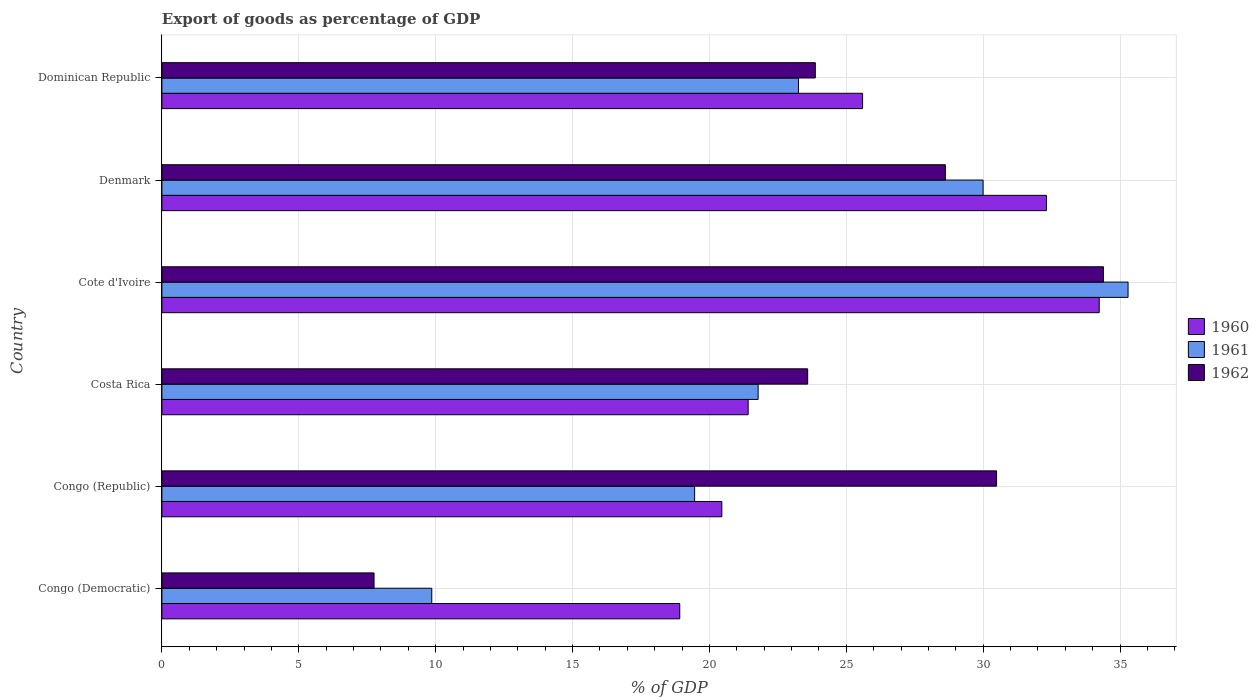How many bars are there on the 2nd tick from the top?
Your answer should be very brief. 3. How many bars are there on the 6th tick from the bottom?
Provide a succinct answer. 3. What is the label of the 5th group of bars from the top?
Offer a very short reply. Congo (Republic). In how many cases, is the number of bars for a given country not equal to the number of legend labels?
Provide a short and direct response. 0. What is the export of goods as percentage of GDP in 1962 in Cote d'Ivoire?
Your response must be concise. 34.39. Across all countries, what is the maximum export of goods as percentage of GDP in 1960?
Provide a short and direct response. 34.24. Across all countries, what is the minimum export of goods as percentage of GDP in 1960?
Ensure brevity in your answer.  18.92. In which country was the export of goods as percentage of GDP in 1962 maximum?
Your answer should be very brief. Cote d'Ivoire. In which country was the export of goods as percentage of GDP in 1962 minimum?
Your answer should be very brief. Congo (Democratic). What is the total export of goods as percentage of GDP in 1960 in the graph?
Your response must be concise. 152.93. What is the difference between the export of goods as percentage of GDP in 1960 in Congo (Republic) and that in Denmark?
Provide a succinct answer. -11.86. What is the difference between the export of goods as percentage of GDP in 1962 in Congo (Republic) and the export of goods as percentage of GDP in 1960 in Dominican Republic?
Make the answer very short. 4.89. What is the average export of goods as percentage of GDP in 1962 per country?
Your response must be concise. 24.78. What is the difference between the export of goods as percentage of GDP in 1960 and export of goods as percentage of GDP in 1961 in Congo (Republic)?
Provide a succinct answer. 0.99. What is the ratio of the export of goods as percentage of GDP in 1961 in Costa Rica to that in Dominican Republic?
Make the answer very short. 0.94. Is the export of goods as percentage of GDP in 1960 in Congo (Democratic) less than that in Dominican Republic?
Your answer should be very brief. Yes. What is the difference between the highest and the second highest export of goods as percentage of GDP in 1961?
Keep it short and to the point. 5.3. What is the difference between the highest and the lowest export of goods as percentage of GDP in 1962?
Give a very brief answer. 26.64. Is the sum of the export of goods as percentage of GDP in 1961 in Congo (Democratic) and Cote d'Ivoire greater than the maximum export of goods as percentage of GDP in 1960 across all countries?
Make the answer very short. Yes. Does the graph contain grids?
Your answer should be compact. Yes. How are the legend labels stacked?
Offer a very short reply. Vertical. What is the title of the graph?
Offer a very short reply. Export of goods as percentage of GDP. What is the label or title of the X-axis?
Your answer should be very brief. % of GDP. What is the label or title of the Y-axis?
Make the answer very short. Country. What is the % of GDP of 1960 in Congo (Democratic)?
Give a very brief answer. 18.92. What is the % of GDP of 1961 in Congo (Democratic)?
Ensure brevity in your answer.  9.86. What is the % of GDP in 1962 in Congo (Democratic)?
Make the answer very short. 7.75. What is the % of GDP in 1960 in Congo (Republic)?
Offer a terse response. 20.45. What is the % of GDP of 1961 in Congo (Republic)?
Offer a terse response. 19.46. What is the % of GDP of 1962 in Congo (Republic)?
Provide a succinct answer. 30.49. What is the % of GDP in 1960 in Costa Rica?
Your answer should be compact. 21.42. What is the % of GDP of 1961 in Costa Rica?
Give a very brief answer. 21.78. What is the % of GDP of 1962 in Costa Rica?
Provide a succinct answer. 23.59. What is the % of GDP in 1960 in Cote d'Ivoire?
Keep it short and to the point. 34.24. What is the % of GDP of 1961 in Cote d'Ivoire?
Provide a succinct answer. 35.29. What is the % of GDP of 1962 in Cote d'Ivoire?
Your answer should be compact. 34.39. What is the % of GDP of 1960 in Denmark?
Make the answer very short. 32.31. What is the % of GDP of 1961 in Denmark?
Your answer should be compact. 30. What is the % of GDP of 1962 in Denmark?
Ensure brevity in your answer.  28.62. What is the % of GDP in 1960 in Dominican Republic?
Keep it short and to the point. 25.59. What is the % of GDP in 1961 in Dominican Republic?
Your response must be concise. 23.25. What is the % of GDP in 1962 in Dominican Republic?
Your answer should be compact. 23.87. Across all countries, what is the maximum % of GDP of 1960?
Ensure brevity in your answer.  34.24. Across all countries, what is the maximum % of GDP of 1961?
Keep it short and to the point. 35.29. Across all countries, what is the maximum % of GDP in 1962?
Ensure brevity in your answer.  34.39. Across all countries, what is the minimum % of GDP of 1960?
Make the answer very short. 18.92. Across all countries, what is the minimum % of GDP of 1961?
Give a very brief answer. 9.86. Across all countries, what is the minimum % of GDP in 1962?
Ensure brevity in your answer.  7.75. What is the total % of GDP of 1960 in the graph?
Offer a terse response. 152.93. What is the total % of GDP in 1961 in the graph?
Your answer should be very brief. 139.64. What is the total % of GDP of 1962 in the graph?
Your response must be concise. 148.71. What is the difference between the % of GDP of 1960 in Congo (Democratic) and that in Congo (Republic)?
Offer a very short reply. -1.54. What is the difference between the % of GDP in 1961 in Congo (Democratic) and that in Congo (Republic)?
Your answer should be very brief. -9.6. What is the difference between the % of GDP of 1962 in Congo (Democratic) and that in Congo (Republic)?
Provide a succinct answer. -22.74. What is the difference between the % of GDP in 1960 in Congo (Democratic) and that in Costa Rica?
Make the answer very short. -2.5. What is the difference between the % of GDP in 1961 in Congo (Democratic) and that in Costa Rica?
Ensure brevity in your answer.  -11.92. What is the difference between the % of GDP of 1962 in Congo (Democratic) and that in Costa Rica?
Your answer should be compact. -15.84. What is the difference between the % of GDP in 1960 in Congo (Democratic) and that in Cote d'Ivoire?
Offer a terse response. -15.32. What is the difference between the % of GDP of 1961 in Congo (Democratic) and that in Cote d'Ivoire?
Ensure brevity in your answer.  -25.43. What is the difference between the % of GDP of 1962 in Congo (Democratic) and that in Cote d'Ivoire?
Provide a short and direct response. -26.64. What is the difference between the % of GDP in 1960 in Congo (Democratic) and that in Denmark?
Your answer should be compact. -13.39. What is the difference between the % of GDP in 1961 in Congo (Democratic) and that in Denmark?
Offer a terse response. -20.14. What is the difference between the % of GDP of 1962 in Congo (Democratic) and that in Denmark?
Offer a terse response. -20.87. What is the difference between the % of GDP in 1960 in Congo (Democratic) and that in Dominican Republic?
Your answer should be compact. -6.68. What is the difference between the % of GDP of 1961 in Congo (Democratic) and that in Dominican Republic?
Offer a very short reply. -13.4. What is the difference between the % of GDP in 1962 in Congo (Democratic) and that in Dominican Republic?
Provide a short and direct response. -16.12. What is the difference between the % of GDP of 1960 in Congo (Republic) and that in Costa Rica?
Offer a terse response. -0.96. What is the difference between the % of GDP in 1961 in Congo (Republic) and that in Costa Rica?
Provide a succinct answer. -2.32. What is the difference between the % of GDP in 1962 in Congo (Republic) and that in Costa Rica?
Your answer should be very brief. 6.9. What is the difference between the % of GDP in 1960 in Congo (Republic) and that in Cote d'Ivoire?
Make the answer very short. -13.79. What is the difference between the % of GDP of 1961 in Congo (Republic) and that in Cote d'Ivoire?
Provide a short and direct response. -15.83. What is the difference between the % of GDP in 1962 in Congo (Republic) and that in Cote d'Ivoire?
Your answer should be very brief. -3.9. What is the difference between the % of GDP in 1960 in Congo (Republic) and that in Denmark?
Offer a very short reply. -11.86. What is the difference between the % of GDP of 1961 in Congo (Republic) and that in Denmark?
Provide a succinct answer. -10.54. What is the difference between the % of GDP of 1962 in Congo (Republic) and that in Denmark?
Ensure brevity in your answer.  1.87. What is the difference between the % of GDP of 1960 in Congo (Republic) and that in Dominican Republic?
Provide a short and direct response. -5.14. What is the difference between the % of GDP of 1961 in Congo (Republic) and that in Dominican Republic?
Your answer should be very brief. -3.79. What is the difference between the % of GDP of 1962 in Congo (Republic) and that in Dominican Republic?
Provide a succinct answer. 6.62. What is the difference between the % of GDP in 1960 in Costa Rica and that in Cote d'Ivoire?
Provide a short and direct response. -12.82. What is the difference between the % of GDP of 1961 in Costa Rica and that in Cote d'Ivoire?
Keep it short and to the point. -13.51. What is the difference between the % of GDP of 1962 in Costa Rica and that in Cote d'Ivoire?
Make the answer very short. -10.8. What is the difference between the % of GDP of 1960 in Costa Rica and that in Denmark?
Keep it short and to the point. -10.89. What is the difference between the % of GDP of 1961 in Costa Rica and that in Denmark?
Offer a terse response. -8.22. What is the difference between the % of GDP in 1962 in Costa Rica and that in Denmark?
Provide a succinct answer. -5.03. What is the difference between the % of GDP in 1960 in Costa Rica and that in Dominican Republic?
Provide a short and direct response. -4.18. What is the difference between the % of GDP of 1961 in Costa Rica and that in Dominican Republic?
Give a very brief answer. -1.47. What is the difference between the % of GDP in 1962 in Costa Rica and that in Dominican Republic?
Ensure brevity in your answer.  -0.28. What is the difference between the % of GDP of 1960 in Cote d'Ivoire and that in Denmark?
Give a very brief answer. 1.93. What is the difference between the % of GDP of 1961 in Cote d'Ivoire and that in Denmark?
Offer a very short reply. 5.3. What is the difference between the % of GDP in 1962 in Cote d'Ivoire and that in Denmark?
Your response must be concise. 5.77. What is the difference between the % of GDP of 1960 in Cote d'Ivoire and that in Dominican Republic?
Provide a short and direct response. 8.64. What is the difference between the % of GDP of 1961 in Cote d'Ivoire and that in Dominican Republic?
Give a very brief answer. 12.04. What is the difference between the % of GDP in 1962 in Cote d'Ivoire and that in Dominican Republic?
Keep it short and to the point. 10.52. What is the difference between the % of GDP in 1960 in Denmark and that in Dominican Republic?
Offer a very short reply. 6.72. What is the difference between the % of GDP in 1961 in Denmark and that in Dominican Republic?
Your response must be concise. 6.74. What is the difference between the % of GDP of 1962 in Denmark and that in Dominican Republic?
Ensure brevity in your answer.  4.75. What is the difference between the % of GDP in 1960 in Congo (Democratic) and the % of GDP in 1961 in Congo (Republic)?
Your answer should be compact. -0.54. What is the difference between the % of GDP in 1960 in Congo (Democratic) and the % of GDP in 1962 in Congo (Republic)?
Your answer should be very brief. -11.57. What is the difference between the % of GDP in 1961 in Congo (Democratic) and the % of GDP in 1962 in Congo (Republic)?
Provide a short and direct response. -20.63. What is the difference between the % of GDP in 1960 in Congo (Democratic) and the % of GDP in 1961 in Costa Rica?
Ensure brevity in your answer.  -2.86. What is the difference between the % of GDP of 1960 in Congo (Democratic) and the % of GDP of 1962 in Costa Rica?
Keep it short and to the point. -4.67. What is the difference between the % of GDP of 1961 in Congo (Democratic) and the % of GDP of 1962 in Costa Rica?
Give a very brief answer. -13.73. What is the difference between the % of GDP in 1960 in Congo (Democratic) and the % of GDP in 1961 in Cote d'Ivoire?
Keep it short and to the point. -16.38. What is the difference between the % of GDP of 1960 in Congo (Democratic) and the % of GDP of 1962 in Cote d'Ivoire?
Give a very brief answer. -15.48. What is the difference between the % of GDP of 1961 in Congo (Democratic) and the % of GDP of 1962 in Cote d'Ivoire?
Offer a terse response. -24.53. What is the difference between the % of GDP in 1960 in Congo (Democratic) and the % of GDP in 1961 in Denmark?
Provide a short and direct response. -11.08. What is the difference between the % of GDP of 1960 in Congo (Democratic) and the % of GDP of 1962 in Denmark?
Ensure brevity in your answer.  -9.7. What is the difference between the % of GDP in 1961 in Congo (Democratic) and the % of GDP in 1962 in Denmark?
Your response must be concise. -18.76. What is the difference between the % of GDP in 1960 in Congo (Democratic) and the % of GDP in 1961 in Dominican Republic?
Give a very brief answer. -4.34. What is the difference between the % of GDP of 1960 in Congo (Democratic) and the % of GDP of 1962 in Dominican Republic?
Ensure brevity in your answer.  -4.95. What is the difference between the % of GDP of 1961 in Congo (Democratic) and the % of GDP of 1962 in Dominican Republic?
Your response must be concise. -14.01. What is the difference between the % of GDP in 1960 in Congo (Republic) and the % of GDP in 1961 in Costa Rica?
Provide a succinct answer. -1.33. What is the difference between the % of GDP of 1960 in Congo (Republic) and the % of GDP of 1962 in Costa Rica?
Make the answer very short. -3.14. What is the difference between the % of GDP of 1961 in Congo (Republic) and the % of GDP of 1962 in Costa Rica?
Keep it short and to the point. -4.13. What is the difference between the % of GDP of 1960 in Congo (Republic) and the % of GDP of 1961 in Cote d'Ivoire?
Provide a succinct answer. -14.84. What is the difference between the % of GDP in 1960 in Congo (Republic) and the % of GDP in 1962 in Cote d'Ivoire?
Give a very brief answer. -13.94. What is the difference between the % of GDP of 1961 in Congo (Republic) and the % of GDP of 1962 in Cote d'Ivoire?
Your answer should be very brief. -14.93. What is the difference between the % of GDP of 1960 in Congo (Republic) and the % of GDP of 1961 in Denmark?
Offer a very short reply. -9.54. What is the difference between the % of GDP of 1960 in Congo (Republic) and the % of GDP of 1962 in Denmark?
Provide a short and direct response. -8.17. What is the difference between the % of GDP in 1961 in Congo (Republic) and the % of GDP in 1962 in Denmark?
Give a very brief answer. -9.16. What is the difference between the % of GDP of 1960 in Congo (Republic) and the % of GDP of 1961 in Dominican Republic?
Ensure brevity in your answer.  -2.8. What is the difference between the % of GDP of 1960 in Congo (Republic) and the % of GDP of 1962 in Dominican Republic?
Ensure brevity in your answer.  -3.42. What is the difference between the % of GDP in 1961 in Congo (Republic) and the % of GDP in 1962 in Dominican Republic?
Keep it short and to the point. -4.41. What is the difference between the % of GDP in 1960 in Costa Rica and the % of GDP in 1961 in Cote d'Ivoire?
Offer a very short reply. -13.88. What is the difference between the % of GDP in 1960 in Costa Rica and the % of GDP in 1962 in Cote d'Ivoire?
Ensure brevity in your answer.  -12.98. What is the difference between the % of GDP in 1961 in Costa Rica and the % of GDP in 1962 in Cote d'Ivoire?
Provide a succinct answer. -12.61. What is the difference between the % of GDP in 1960 in Costa Rica and the % of GDP in 1961 in Denmark?
Offer a very short reply. -8.58. What is the difference between the % of GDP in 1960 in Costa Rica and the % of GDP in 1962 in Denmark?
Give a very brief answer. -7.2. What is the difference between the % of GDP in 1961 in Costa Rica and the % of GDP in 1962 in Denmark?
Keep it short and to the point. -6.84. What is the difference between the % of GDP in 1960 in Costa Rica and the % of GDP in 1961 in Dominican Republic?
Your answer should be compact. -1.84. What is the difference between the % of GDP in 1960 in Costa Rica and the % of GDP in 1962 in Dominican Republic?
Provide a short and direct response. -2.45. What is the difference between the % of GDP in 1961 in Costa Rica and the % of GDP in 1962 in Dominican Republic?
Your response must be concise. -2.09. What is the difference between the % of GDP in 1960 in Cote d'Ivoire and the % of GDP in 1961 in Denmark?
Keep it short and to the point. 4.24. What is the difference between the % of GDP in 1960 in Cote d'Ivoire and the % of GDP in 1962 in Denmark?
Offer a very short reply. 5.62. What is the difference between the % of GDP in 1961 in Cote d'Ivoire and the % of GDP in 1962 in Denmark?
Your response must be concise. 6.67. What is the difference between the % of GDP of 1960 in Cote d'Ivoire and the % of GDP of 1961 in Dominican Republic?
Offer a terse response. 10.99. What is the difference between the % of GDP in 1960 in Cote d'Ivoire and the % of GDP in 1962 in Dominican Republic?
Keep it short and to the point. 10.37. What is the difference between the % of GDP in 1961 in Cote d'Ivoire and the % of GDP in 1962 in Dominican Republic?
Ensure brevity in your answer.  11.42. What is the difference between the % of GDP in 1960 in Denmark and the % of GDP in 1961 in Dominican Republic?
Give a very brief answer. 9.06. What is the difference between the % of GDP in 1960 in Denmark and the % of GDP in 1962 in Dominican Republic?
Your answer should be very brief. 8.44. What is the difference between the % of GDP in 1961 in Denmark and the % of GDP in 1962 in Dominican Republic?
Your response must be concise. 6.13. What is the average % of GDP of 1960 per country?
Keep it short and to the point. 25.49. What is the average % of GDP of 1961 per country?
Your answer should be very brief. 23.27. What is the average % of GDP of 1962 per country?
Your answer should be compact. 24.78. What is the difference between the % of GDP in 1960 and % of GDP in 1961 in Congo (Democratic)?
Offer a terse response. 9.06. What is the difference between the % of GDP in 1960 and % of GDP in 1962 in Congo (Democratic)?
Your answer should be very brief. 11.17. What is the difference between the % of GDP in 1961 and % of GDP in 1962 in Congo (Democratic)?
Keep it short and to the point. 2.11. What is the difference between the % of GDP of 1960 and % of GDP of 1961 in Congo (Republic)?
Keep it short and to the point. 0.99. What is the difference between the % of GDP in 1960 and % of GDP in 1962 in Congo (Republic)?
Your answer should be very brief. -10.04. What is the difference between the % of GDP in 1961 and % of GDP in 1962 in Congo (Republic)?
Your answer should be very brief. -11.03. What is the difference between the % of GDP of 1960 and % of GDP of 1961 in Costa Rica?
Provide a short and direct response. -0.36. What is the difference between the % of GDP of 1960 and % of GDP of 1962 in Costa Rica?
Make the answer very short. -2.17. What is the difference between the % of GDP of 1961 and % of GDP of 1962 in Costa Rica?
Offer a terse response. -1.81. What is the difference between the % of GDP in 1960 and % of GDP in 1961 in Cote d'Ivoire?
Ensure brevity in your answer.  -1.05. What is the difference between the % of GDP of 1960 and % of GDP of 1962 in Cote d'Ivoire?
Your answer should be very brief. -0.15. What is the difference between the % of GDP of 1961 and % of GDP of 1962 in Cote d'Ivoire?
Offer a terse response. 0.9. What is the difference between the % of GDP in 1960 and % of GDP in 1961 in Denmark?
Provide a succinct answer. 2.31. What is the difference between the % of GDP in 1960 and % of GDP in 1962 in Denmark?
Provide a succinct answer. 3.69. What is the difference between the % of GDP in 1961 and % of GDP in 1962 in Denmark?
Offer a very short reply. 1.38. What is the difference between the % of GDP in 1960 and % of GDP in 1961 in Dominican Republic?
Your answer should be very brief. 2.34. What is the difference between the % of GDP in 1960 and % of GDP in 1962 in Dominican Republic?
Your answer should be compact. 1.73. What is the difference between the % of GDP in 1961 and % of GDP in 1962 in Dominican Republic?
Provide a short and direct response. -0.62. What is the ratio of the % of GDP of 1960 in Congo (Democratic) to that in Congo (Republic)?
Offer a terse response. 0.92. What is the ratio of the % of GDP in 1961 in Congo (Democratic) to that in Congo (Republic)?
Give a very brief answer. 0.51. What is the ratio of the % of GDP in 1962 in Congo (Democratic) to that in Congo (Republic)?
Offer a terse response. 0.25. What is the ratio of the % of GDP of 1960 in Congo (Democratic) to that in Costa Rica?
Make the answer very short. 0.88. What is the ratio of the % of GDP in 1961 in Congo (Democratic) to that in Costa Rica?
Provide a short and direct response. 0.45. What is the ratio of the % of GDP in 1962 in Congo (Democratic) to that in Costa Rica?
Your answer should be compact. 0.33. What is the ratio of the % of GDP of 1960 in Congo (Democratic) to that in Cote d'Ivoire?
Your answer should be compact. 0.55. What is the ratio of the % of GDP in 1961 in Congo (Democratic) to that in Cote d'Ivoire?
Give a very brief answer. 0.28. What is the ratio of the % of GDP of 1962 in Congo (Democratic) to that in Cote d'Ivoire?
Your answer should be compact. 0.23. What is the ratio of the % of GDP in 1960 in Congo (Democratic) to that in Denmark?
Make the answer very short. 0.59. What is the ratio of the % of GDP in 1961 in Congo (Democratic) to that in Denmark?
Your answer should be compact. 0.33. What is the ratio of the % of GDP in 1962 in Congo (Democratic) to that in Denmark?
Your answer should be very brief. 0.27. What is the ratio of the % of GDP in 1960 in Congo (Democratic) to that in Dominican Republic?
Ensure brevity in your answer.  0.74. What is the ratio of the % of GDP of 1961 in Congo (Democratic) to that in Dominican Republic?
Ensure brevity in your answer.  0.42. What is the ratio of the % of GDP of 1962 in Congo (Democratic) to that in Dominican Republic?
Provide a short and direct response. 0.32. What is the ratio of the % of GDP of 1960 in Congo (Republic) to that in Costa Rica?
Offer a very short reply. 0.96. What is the ratio of the % of GDP in 1961 in Congo (Republic) to that in Costa Rica?
Ensure brevity in your answer.  0.89. What is the ratio of the % of GDP in 1962 in Congo (Republic) to that in Costa Rica?
Make the answer very short. 1.29. What is the ratio of the % of GDP in 1960 in Congo (Republic) to that in Cote d'Ivoire?
Your answer should be very brief. 0.6. What is the ratio of the % of GDP in 1961 in Congo (Republic) to that in Cote d'Ivoire?
Provide a short and direct response. 0.55. What is the ratio of the % of GDP of 1962 in Congo (Republic) to that in Cote d'Ivoire?
Your response must be concise. 0.89. What is the ratio of the % of GDP in 1960 in Congo (Republic) to that in Denmark?
Give a very brief answer. 0.63. What is the ratio of the % of GDP of 1961 in Congo (Republic) to that in Denmark?
Provide a succinct answer. 0.65. What is the ratio of the % of GDP of 1962 in Congo (Republic) to that in Denmark?
Ensure brevity in your answer.  1.07. What is the ratio of the % of GDP of 1960 in Congo (Republic) to that in Dominican Republic?
Keep it short and to the point. 0.8. What is the ratio of the % of GDP in 1961 in Congo (Republic) to that in Dominican Republic?
Keep it short and to the point. 0.84. What is the ratio of the % of GDP of 1962 in Congo (Republic) to that in Dominican Republic?
Provide a short and direct response. 1.28. What is the ratio of the % of GDP of 1960 in Costa Rica to that in Cote d'Ivoire?
Offer a terse response. 0.63. What is the ratio of the % of GDP of 1961 in Costa Rica to that in Cote d'Ivoire?
Your answer should be compact. 0.62. What is the ratio of the % of GDP of 1962 in Costa Rica to that in Cote d'Ivoire?
Keep it short and to the point. 0.69. What is the ratio of the % of GDP in 1960 in Costa Rica to that in Denmark?
Keep it short and to the point. 0.66. What is the ratio of the % of GDP of 1961 in Costa Rica to that in Denmark?
Make the answer very short. 0.73. What is the ratio of the % of GDP in 1962 in Costa Rica to that in Denmark?
Make the answer very short. 0.82. What is the ratio of the % of GDP in 1960 in Costa Rica to that in Dominican Republic?
Provide a succinct answer. 0.84. What is the ratio of the % of GDP in 1961 in Costa Rica to that in Dominican Republic?
Keep it short and to the point. 0.94. What is the ratio of the % of GDP of 1962 in Costa Rica to that in Dominican Republic?
Provide a succinct answer. 0.99. What is the ratio of the % of GDP of 1960 in Cote d'Ivoire to that in Denmark?
Ensure brevity in your answer.  1.06. What is the ratio of the % of GDP of 1961 in Cote d'Ivoire to that in Denmark?
Give a very brief answer. 1.18. What is the ratio of the % of GDP in 1962 in Cote d'Ivoire to that in Denmark?
Give a very brief answer. 1.2. What is the ratio of the % of GDP in 1960 in Cote d'Ivoire to that in Dominican Republic?
Make the answer very short. 1.34. What is the ratio of the % of GDP in 1961 in Cote d'Ivoire to that in Dominican Republic?
Keep it short and to the point. 1.52. What is the ratio of the % of GDP of 1962 in Cote d'Ivoire to that in Dominican Republic?
Offer a very short reply. 1.44. What is the ratio of the % of GDP in 1960 in Denmark to that in Dominican Republic?
Keep it short and to the point. 1.26. What is the ratio of the % of GDP of 1961 in Denmark to that in Dominican Republic?
Provide a succinct answer. 1.29. What is the ratio of the % of GDP of 1962 in Denmark to that in Dominican Republic?
Your answer should be compact. 1.2. What is the difference between the highest and the second highest % of GDP in 1960?
Your answer should be compact. 1.93. What is the difference between the highest and the second highest % of GDP in 1961?
Your answer should be compact. 5.3. What is the difference between the highest and the second highest % of GDP of 1962?
Offer a terse response. 3.9. What is the difference between the highest and the lowest % of GDP of 1960?
Your answer should be very brief. 15.32. What is the difference between the highest and the lowest % of GDP in 1961?
Ensure brevity in your answer.  25.43. What is the difference between the highest and the lowest % of GDP in 1962?
Offer a terse response. 26.64. 